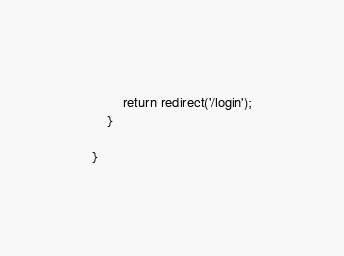Convert code to text. <code><loc_0><loc_0><loc_500><loc_500><_PHP_>        return redirect('/login');
    }    

}</code> 